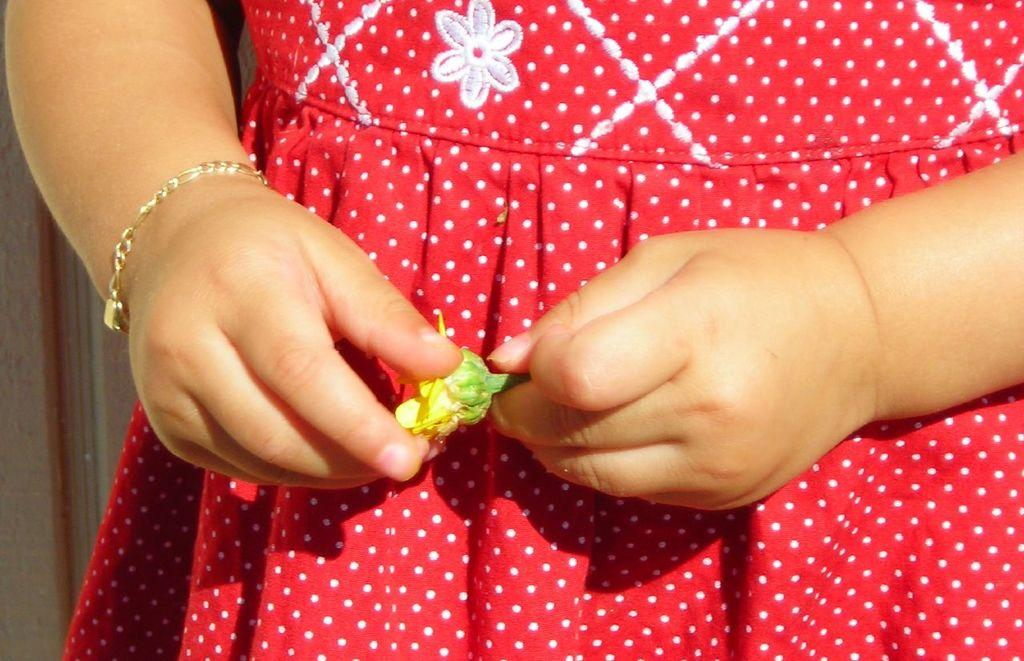What is the person holding in the image? The person's hands are holding a yellow and green object. What type of accessory is the person wearing on their wrist? The person is wearing a bracelet. What color is the dress the person is wearing? The person is wearing a red dress. What type of game is the person playing with their nose in the image? There is no game or nose-related activity depicted in the image. 